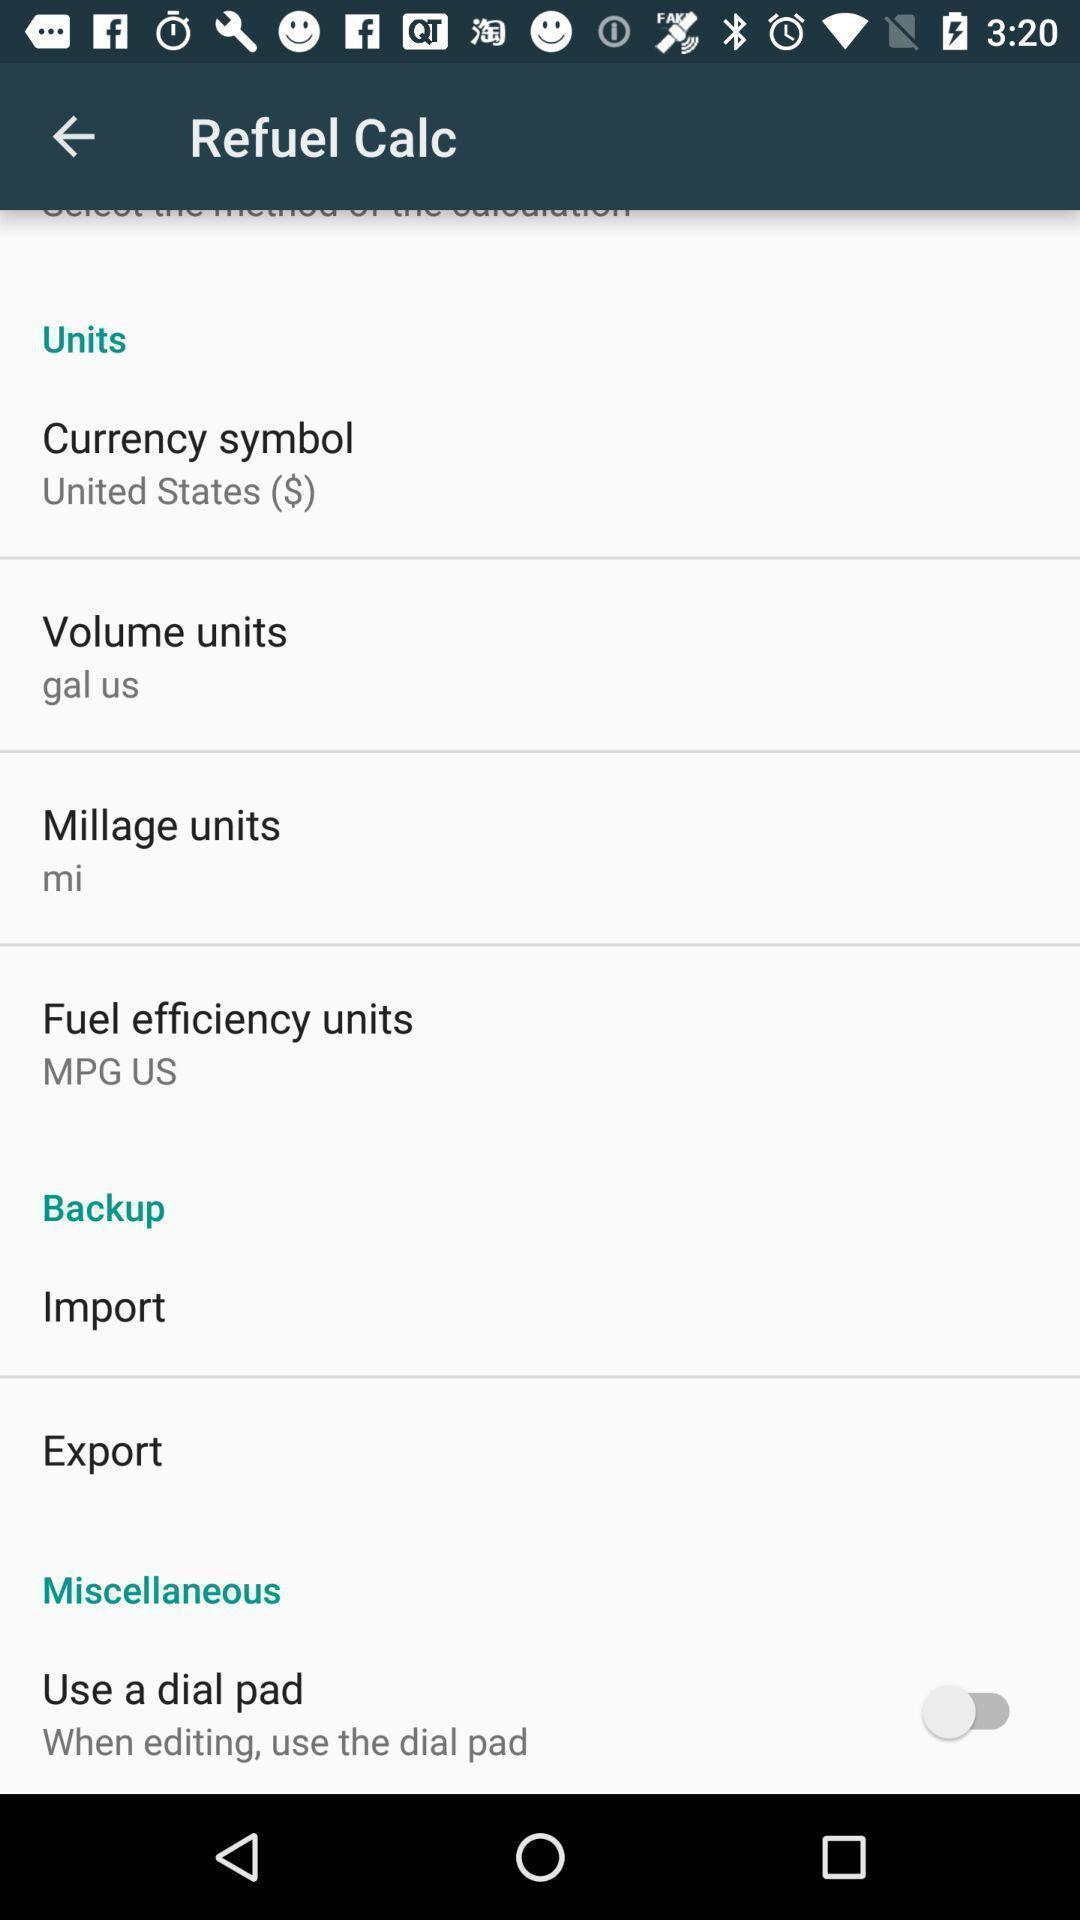Summarize the main components in this picture. Unit adjustment options page in a fuel economy app. 